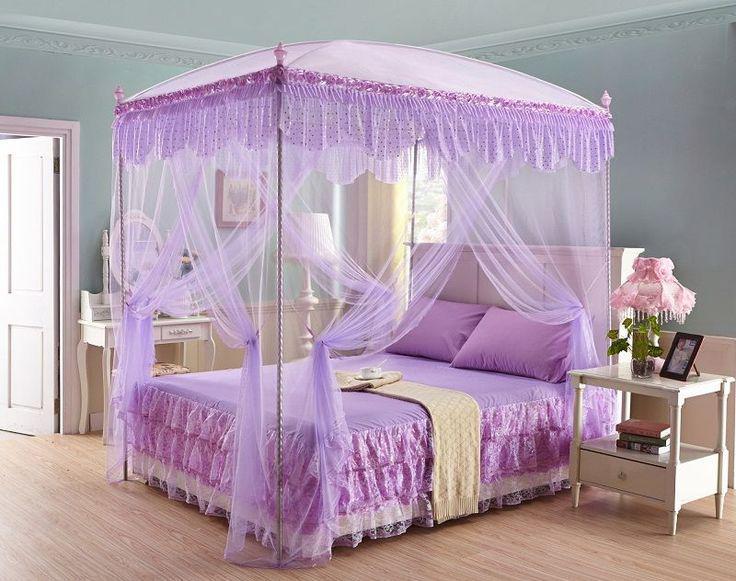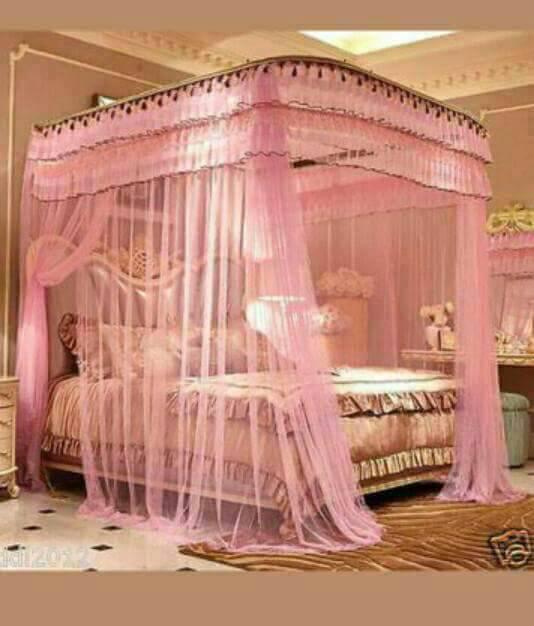The first image is the image on the left, the second image is the image on the right. For the images shown, is this caption "The bed in one of the images is surrounded by purple netting" true? Answer yes or no. Yes. The first image is the image on the left, the second image is the image on the right. For the images shown, is this caption "All bed canopies are the same shape as the bed with a deep ruffle at the top and sheer curtains draping down." true? Answer yes or no. Yes. 